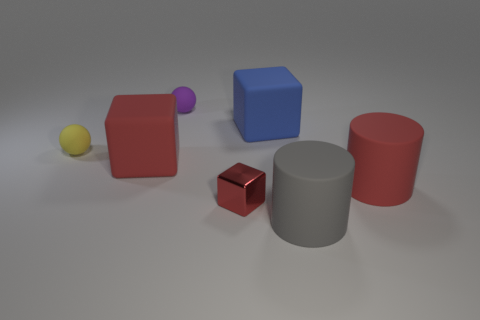The gray object that is the same size as the blue rubber block is what shape?
Your answer should be compact. Cylinder. There is a purple rubber object that is on the left side of the gray cylinder; is its size the same as the rubber cylinder to the right of the gray rubber cylinder?
Your answer should be compact. No. There is another large cube that is made of the same material as the big red cube; what color is it?
Your response must be concise. Blue. Is the material of the large cube on the left side of the purple matte thing the same as the big thing that is behind the tiny yellow matte object?
Your response must be concise. Yes. Are there any gray things that have the same size as the yellow object?
Your answer should be compact. No. There is a rubber block on the right side of the sphere behind the blue thing; what size is it?
Offer a terse response. Large. What number of matte things have the same color as the tiny shiny block?
Provide a succinct answer. 2. There is a red rubber object that is in front of the large matte block in front of the tiny yellow sphere; what shape is it?
Your answer should be compact. Cylinder. What number of large things are the same material as the small yellow ball?
Your answer should be very brief. 4. There is a cube that is to the right of the tiny metal cube; what is its material?
Keep it short and to the point. Rubber. 